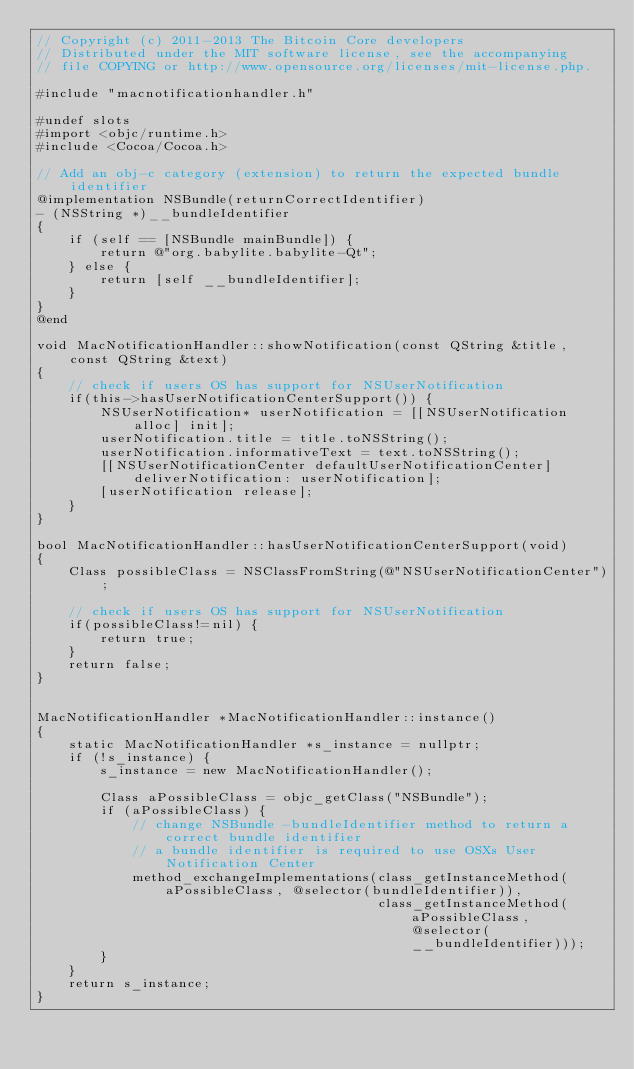Convert code to text. <code><loc_0><loc_0><loc_500><loc_500><_ObjectiveC_>// Copyright (c) 2011-2013 The Bitcoin Core developers
// Distributed under the MIT software license, see the accompanying
// file COPYING or http://www.opensource.org/licenses/mit-license.php.

#include "macnotificationhandler.h"

#undef slots
#import <objc/runtime.h>
#include <Cocoa/Cocoa.h>

// Add an obj-c category (extension) to return the expected bundle identifier
@implementation NSBundle(returnCorrectIdentifier)
- (NSString *)__bundleIdentifier
{
    if (self == [NSBundle mainBundle]) {
        return @"org.babylite.babylite-Qt";
    } else {
        return [self __bundleIdentifier];
    }
}
@end

void MacNotificationHandler::showNotification(const QString &title, const QString &text)
{
    // check if users OS has support for NSUserNotification
    if(this->hasUserNotificationCenterSupport()) {
        NSUserNotification* userNotification = [[NSUserNotification alloc] init];
        userNotification.title = title.toNSString();
        userNotification.informativeText = text.toNSString();
        [[NSUserNotificationCenter defaultUserNotificationCenter] deliverNotification: userNotification];
        [userNotification release];
    }
}

bool MacNotificationHandler::hasUserNotificationCenterSupport(void)
{
    Class possibleClass = NSClassFromString(@"NSUserNotificationCenter");

    // check if users OS has support for NSUserNotification
    if(possibleClass!=nil) {
        return true;
    }
    return false;
}


MacNotificationHandler *MacNotificationHandler::instance()
{
    static MacNotificationHandler *s_instance = nullptr;
    if (!s_instance) {
        s_instance = new MacNotificationHandler();

        Class aPossibleClass = objc_getClass("NSBundle");
        if (aPossibleClass) {
            // change NSBundle -bundleIdentifier method to return a correct bundle identifier
            // a bundle identifier is required to use OSXs User Notification Center
            method_exchangeImplementations(class_getInstanceMethod(aPossibleClass, @selector(bundleIdentifier)),
                                           class_getInstanceMethod(aPossibleClass, @selector(__bundleIdentifier)));
        }
    }
    return s_instance;
}
</code> 